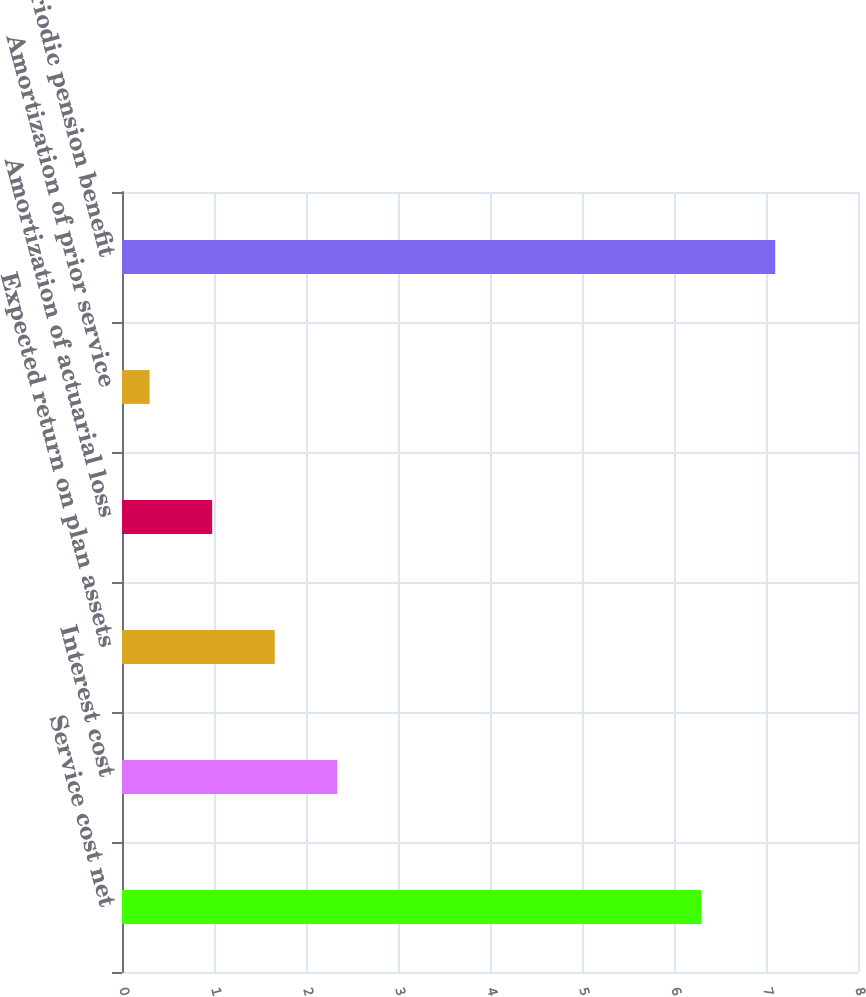<chart> <loc_0><loc_0><loc_500><loc_500><bar_chart><fcel>Service cost net<fcel>Interest cost<fcel>Expected return on plan assets<fcel>Amortization of actuarial loss<fcel>Amortization of prior service<fcel>Net periodic pension benefit<nl><fcel>6.3<fcel>2.34<fcel>1.66<fcel>0.98<fcel>0.3<fcel>7.1<nl></chart> 